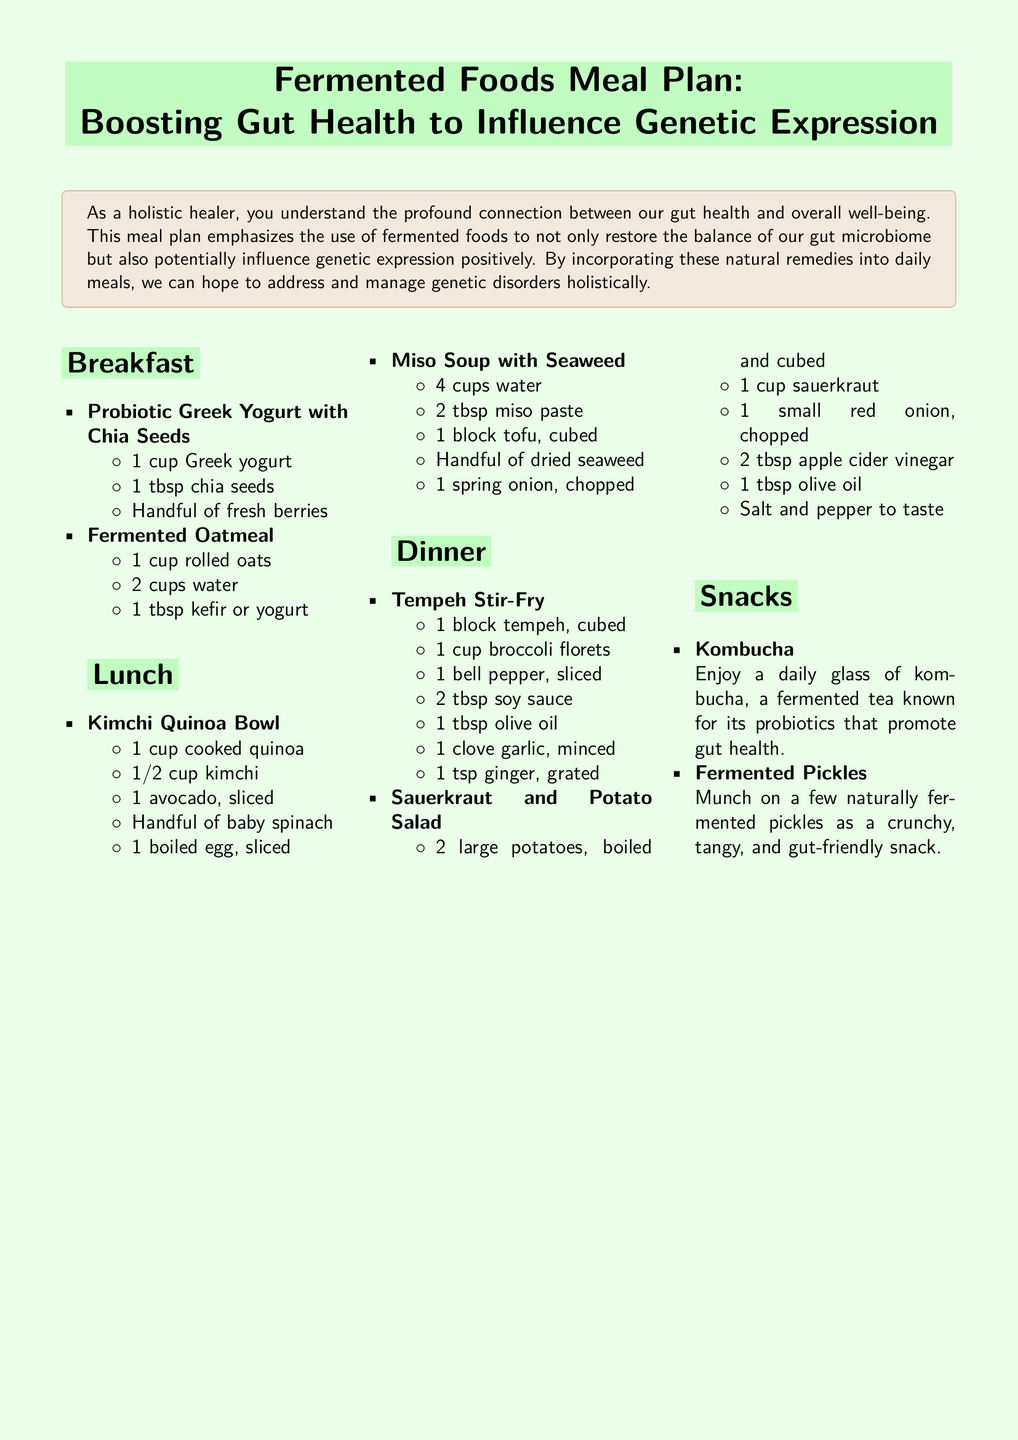what is the first breakfast item listed? The first breakfast item listed in the document is "Probiotic Greek Yogurt with Chia Seeds."
Answer: Probiotic Greek Yogurt with Chia Seeds how many meals are included in the meal plan? The meal plan includes three main meals: breakfast, lunch, and dinner.
Answer: Three what fermented food is mentioned as a snack? The snack mentioned in the document is "Fermented Pickles."
Answer: Fermented Pickles which meal includes kimchi? The "Kimchi Quinoa Bowl" for lunch includes kimchi.
Answer: Kimchi Quinoa Bowl what is used to make fermented oatmeal? Fermented oatmeal is made using rolled oats and kefir or yogurt.
Answer: Rolled oats and kefir or yogurt how many tablespoons of miso paste are in the miso soup? The miso soup requires 2 tablespoons of miso paste.
Answer: 2 tablespoons what ingredient is used for flavoring in the Tempeh Stir-Fry? The flavoring in the Tempeh Stir-Fry includes garlic and ginger.
Answer: Garlic and ginger what type of yogurt is used in the breakfast? The breakfast uses "Greek yogurt."
Answer: Greek yogurt what vegetable is included in the Sauerkraut and Potato Salad? The vegetable included in the Sauerkraut and Potato Salad is "red onion."
Answer: Red onion 